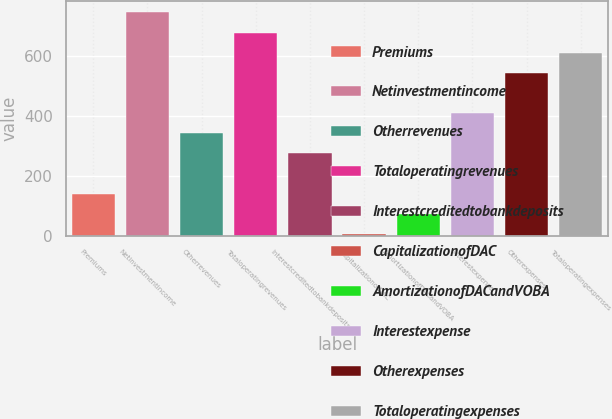<chart> <loc_0><loc_0><loc_500><loc_500><bar_chart><fcel>Premiums<fcel>Netinvestmentincome<fcel>Otherrevenues<fcel>Totaloperatingrevenues<fcel>Interestcreditedtobankdeposits<fcel>CapitalizationofDAC<fcel>AmortizationofDACandVOBA<fcel>Interestexpense<fcel>Otherexpenses<fcel>Totaloperatingexpenses<nl><fcel>139.8<fcel>746.4<fcel>342<fcel>679<fcel>274.6<fcel>5<fcel>72.4<fcel>409.4<fcel>544.2<fcel>611.6<nl></chart> 